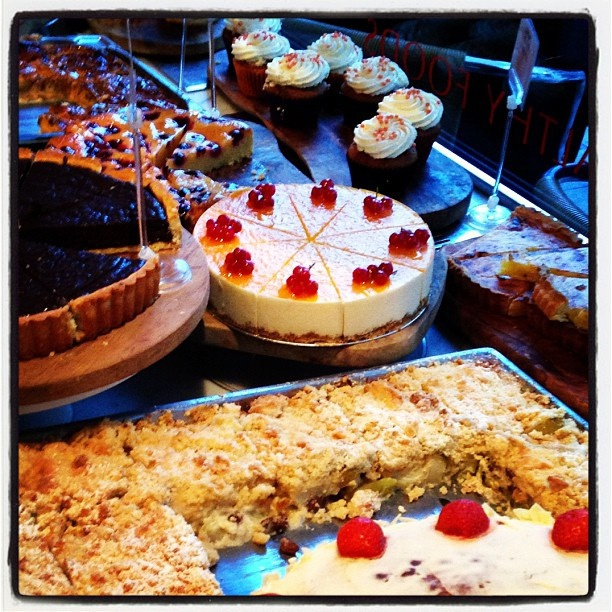Describe the objects in this image and their specific colors. I can see cake in white, orange, tan, and brown tones, cake in white, ivory, black, maroon, and khaki tones, cake in white, lavender, tan, brown, and maroon tones, cake in white, black, maroon, and brown tones, and cake in white, black, darkgray, lightgray, and tan tones in this image. 